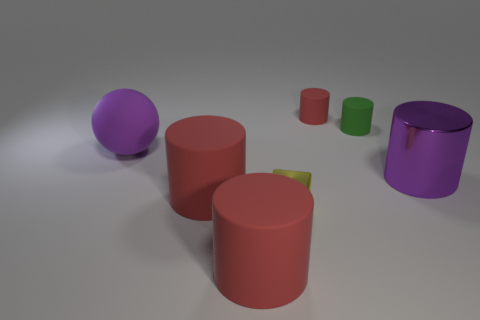There is a object that is the same color as the sphere; what is its material?
Offer a terse response. Metal. What is the material of the small cube?
Make the answer very short. Metal. There is a cylinder that is in front of the red thing that is left of the large red object that is in front of the tiny metallic cube; what is its material?
Offer a terse response. Rubber. Is the color of the big metal cylinder the same as the large rubber cylinder that is behind the small cube?
Provide a succinct answer. No. Is there anything else that is the same shape as the green matte object?
Your answer should be very brief. Yes. What is the color of the large cylinder that is in front of the big red object behind the small cube?
Ensure brevity in your answer.  Red. What number of large red metal balls are there?
Make the answer very short. 0. How many metal things are either tiny green cylinders or small things?
Keep it short and to the point. 1. What number of other tiny shiny blocks have the same color as the shiny cube?
Give a very brief answer. 0. There is a purple thing in front of the big purple thing to the left of the large purple cylinder; what is it made of?
Ensure brevity in your answer.  Metal. 